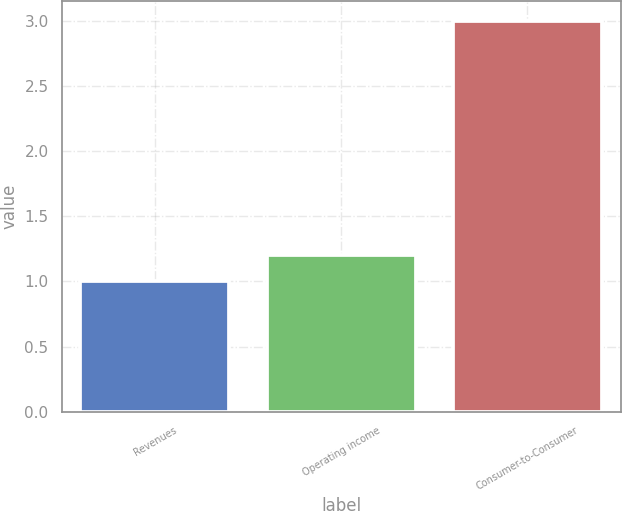<chart> <loc_0><loc_0><loc_500><loc_500><bar_chart><fcel>Revenues<fcel>Operating income<fcel>Consumer-to-Consumer<nl><fcel>1<fcel>1.2<fcel>3<nl></chart> 